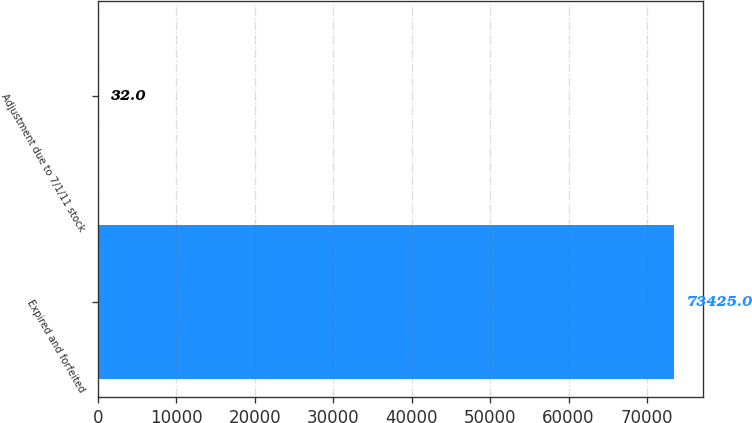Convert chart to OTSL. <chart><loc_0><loc_0><loc_500><loc_500><bar_chart><fcel>Expired and forfeited<fcel>Adjustment due to 7/1/11 stock<nl><fcel>73425<fcel>32<nl></chart> 